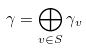<formula> <loc_0><loc_0><loc_500><loc_500>\gamma = \bigoplus _ { v \in S } \gamma _ { v }</formula> 